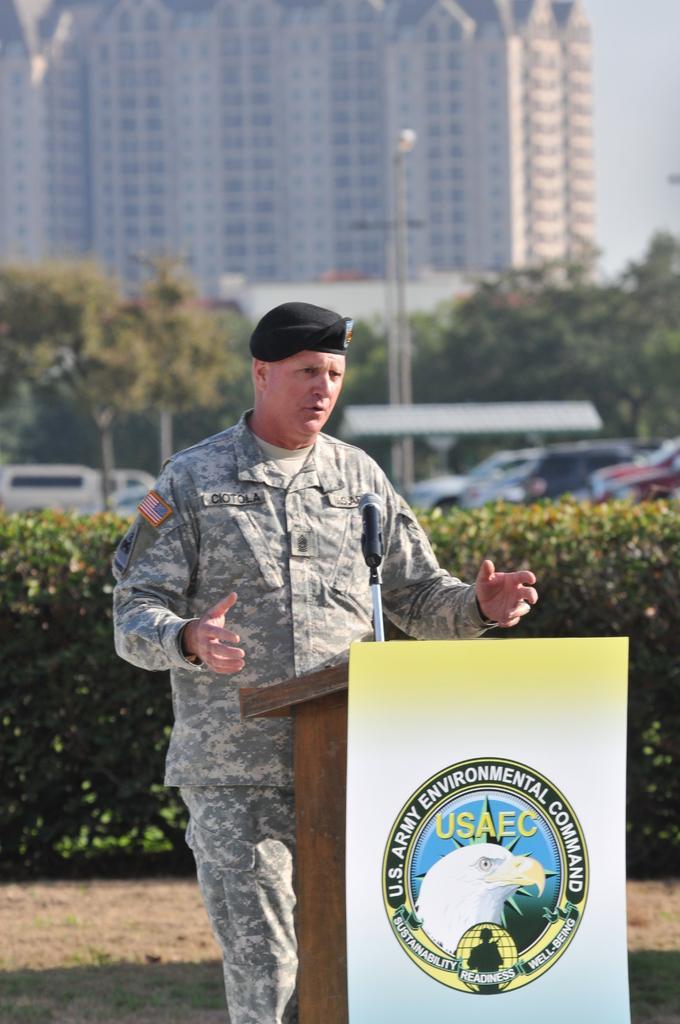Can you describe this image briefly? In this image we can see there is a person talking. And in front there is a podium and a mike. And at the back there are trees and vehicles. And there is a street light, Building and shed. And at the top there is a sky. 